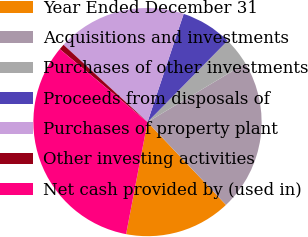Convert chart. <chart><loc_0><loc_0><loc_500><loc_500><pie_chart><fcel>Year Ended December 31<fcel>Acquisitions and investments<fcel>Purchases of other investments<fcel>Proceeds from disposals of<fcel>Purchases of property plant<fcel>Other investing activities<fcel>Net cash provided by (used in)<nl><fcel>15.08%<fcel>21.53%<fcel>4.02%<fcel>7.24%<fcel>18.3%<fcel>0.8%<fcel>33.04%<nl></chart> 